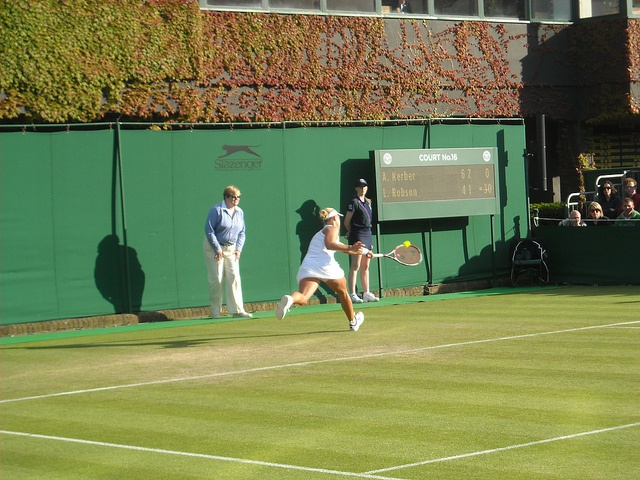Describe the objects in this image and their specific colors. I can see people in darkgreen, white, teal, darkgray, and gray tones, people in darkgreen, white, darkgray, tan, and maroon tones, people in darkgreen, black, gray, and ivory tones, people in darkgreen, black, gray, and maroon tones, and tennis racket in darkgreen, tan, ivory, darkgray, and green tones in this image. 